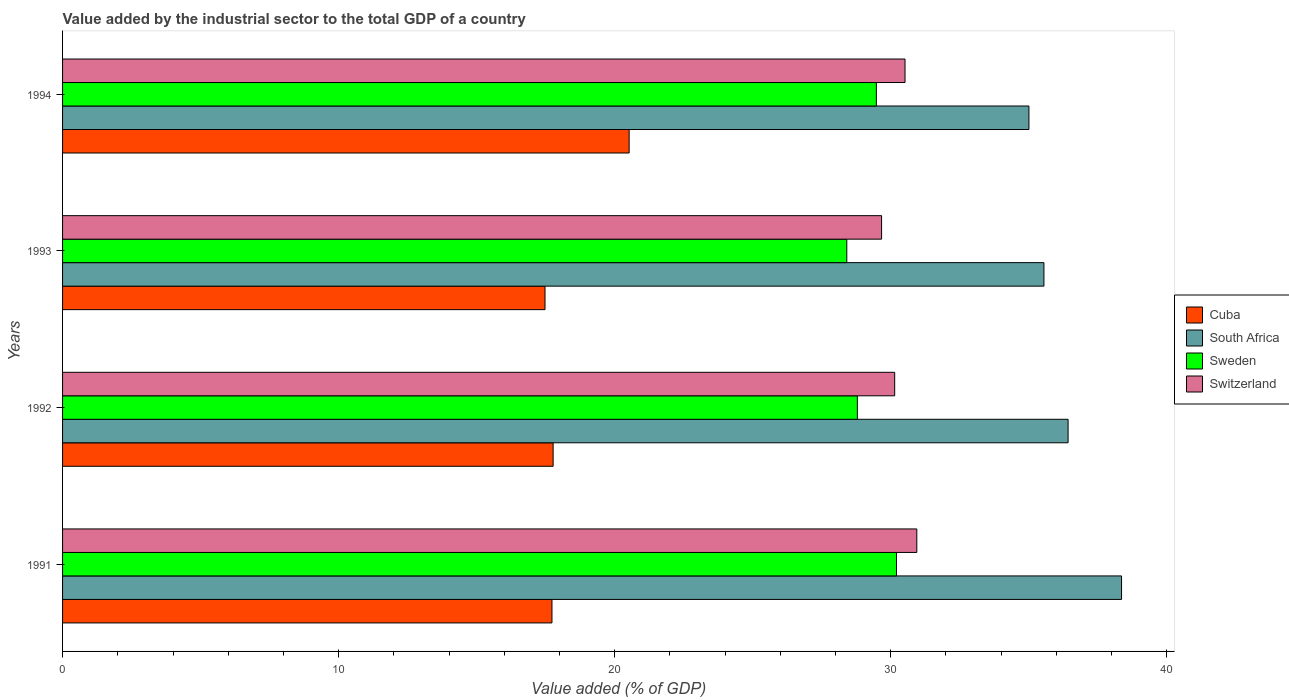How many different coloured bars are there?
Provide a short and direct response. 4. How many bars are there on the 3rd tick from the bottom?
Your answer should be very brief. 4. What is the label of the 1st group of bars from the top?
Your answer should be very brief. 1994. What is the value added by the industrial sector to the total GDP in South Africa in 1994?
Ensure brevity in your answer.  35. Across all years, what is the maximum value added by the industrial sector to the total GDP in Sweden?
Offer a terse response. 30.21. Across all years, what is the minimum value added by the industrial sector to the total GDP in Sweden?
Provide a succinct answer. 28.41. In which year was the value added by the industrial sector to the total GDP in Switzerland minimum?
Provide a short and direct response. 1993. What is the total value added by the industrial sector to the total GDP in Sweden in the graph?
Your answer should be compact. 116.88. What is the difference between the value added by the industrial sector to the total GDP in Cuba in 1991 and that in 1994?
Your response must be concise. -2.8. What is the difference between the value added by the industrial sector to the total GDP in Cuba in 1994 and the value added by the industrial sector to the total GDP in South Africa in 1991?
Provide a succinct answer. -17.84. What is the average value added by the industrial sector to the total GDP in Cuba per year?
Keep it short and to the point. 18.37. In the year 1994, what is the difference between the value added by the industrial sector to the total GDP in South Africa and value added by the industrial sector to the total GDP in Switzerland?
Your answer should be compact. 4.49. What is the ratio of the value added by the industrial sector to the total GDP in Cuba in 1991 to that in 1993?
Ensure brevity in your answer.  1.01. Is the value added by the industrial sector to the total GDP in Switzerland in 1993 less than that in 1994?
Your response must be concise. Yes. What is the difference between the highest and the second highest value added by the industrial sector to the total GDP in South Africa?
Offer a terse response. 1.94. What is the difference between the highest and the lowest value added by the industrial sector to the total GDP in Cuba?
Offer a terse response. 3.05. In how many years, is the value added by the industrial sector to the total GDP in Cuba greater than the average value added by the industrial sector to the total GDP in Cuba taken over all years?
Provide a succinct answer. 1. Is it the case that in every year, the sum of the value added by the industrial sector to the total GDP in Cuba and value added by the industrial sector to the total GDP in Sweden is greater than the sum of value added by the industrial sector to the total GDP in South Africa and value added by the industrial sector to the total GDP in Switzerland?
Provide a short and direct response. No. What does the 3rd bar from the top in 1994 represents?
Ensure brevity in your answer.  South Africa. What does the 4th bar from the bottom in 1993 represents?
Your answer should be compact. Switzerland. Is it the case that in every year, the sum of the value added by the industrial sector to the total GDP in Switzerland and value added by the industrial sector to the total GDP in South Africa is greater than the value added by the industrial sector to the total GDP in Sweden?
Provide a short and direct response. Yes. How many bars are there?
Make the answer very short. 16. Are all the bars in the graph horizontal?
Your answer should be very brief. Yes. How many years are there in the graph?
Your answer should be compact. 4. What is the difference between two consecutive major ticks on the X-axis?
Provide a succinct answer. 10. Does the graph contain any zero values?
Make the answer very short. No. Where does the legend appear in the graph?
Ensure brevity in your answer.  Center right. How many legend labels are there?
Give a very brief answer. 4. What is the title of the graph?
Keep it short and to the point. Value added by the industrial sector to the total GDP of a country. Does "Trinidad and Tobago" appear as one of the legend labels in the graph?
Make the answer very short. No. What is the label or title of the X-axis?
Your response must be concise. Value added (% of GDP). What is the Value added (% of GDP) in Cuba in 1991?
Give a very brief answer. 17.73. What is the Value added (% of GDP) of South Africa in 1991?
Make the answer very short. 38.36. What is the Value added (% of GDP) in Sweden in 1991?
Give a very brief answer. 30.21. What is the Value added (% of GDP) of Switzerland in 1991?
Ensure brevity in your answer.  30.94. What is the Value added (% of GDP) of Cuba in 1992?
Offer a terse response. 17.77. What is the Value added (% of GDP) in South Africa in 1992?
Offer a very short reply. 36.42. What is the Value added (% of GDP) of Sweden in 1992?
Your answer should be very brief. 28.79. What is the Value added (% of GDP) in Switzerland in 1992?
Your answer should be very brief. 30.14. What is the Value added (% of GDP) of Cuba in 1993?
Provide a succinct answer. 17.48. What is the Value added (% of GDP) of South Africa in 1993?
Ensure brevity in your answer.  35.55. What is the Value added (% of GDP) in Sweden in 1993?
Provide a short and direct response. 28.41. What is the Value added (% of GDP) of Switzerland in 1993?
Your response must be concise. 29.67. What is the Value added (% of GDP) of Cuba in 1994?
Make the answer very short. 20.52. What is the Value added (% of GDP) of South Africa in 1994?
Give a very brief answer. 35. What is the Value added (% of GDP) in Sweden in 1994?
Your answer should be compact. 29.48. What is the Value added (% of GDP) of Switzerland in 1994?
Give a very brief answer. 30.52. Across all years, what is the maximum Value added (% of GDP) in Cuba?
Provide a short and direct response. 20.52. Across all years, what is the maximum Value added (% of GDP) of South Africa?
Provide a short and direct response. 38.36. Across all years, what is the maximum Value added (% of GDP) in Sweden?
Offer a terse response. 30.21. Across all years, what is the maximum Value added (% of GDP) of Switzerland?
Keep it short and to the point. 30.94. Across all years, what is the minimum Value added (% of GDP) of Cuba?
Ensure brevity in your answer.  17.48. Across all years, what is the minimum Value added (% of GDP) of South Africa?
Make the answer very short. 35. Across all years, what is the minimum Value added (% of GDP) of Sweden?
Provide a short and direct response. 28.41. Across all years, what is the minimum Value added (% of GDP) in Switzerland?
Your answer should be very brief. 29.67. What is the total Value added (% of GDP) of Cuba in the graph?
Provide a short and direct response. 73.5. What is the total Value added (% of GDP) in South Africa in the graph?
Your response must be concise. 145.34. What is the total Value added (% of GDP) in Sweden in the graph?
Make the answer very short. 116.88. What is the total Value added (% of GDP) in Switzerland in the graph?
Ensure brevity in your answer.  121.27. What is the difference between the Value added (% of GDP) in Cuba in 1991 and that in 1992?
Your answer should be compact. -0.04. What is the difference between the Value added (% of GDP) of South Africa in 1991 and that in 1992?
Your answer should be very brief. 1.94. What is the difference between the Value added (% of GDP) of Sweden in 1991 and that in 1992?
Your response must be concise. 1.42. What is the difference between the Value added (% of GDP) of Switzerland in 1991 and that in 1992?
Your answer should be very brief. 0.8. What is the difference between the Value added (% of GDP) of Cuba in 1991 and that in 1993?
Keep it short and to the point. 0.25. What is the difference between the Value added (% of GDP) of South Africa in 1991 and that in 1993?
Provide a succinct answer. 2.81. What is the difference between the Value added (% of GDP) in Sweden in 1991 and that in 1993?
Give a very brief answer. 1.8. What is the difference between the Value added (% of GDP) in Switzerland in 1991 and that in 1993?
Make the answer very short. 1.28. What is the difference between the Value added (% of GDP) in Cuba in 1991 and that in 1994?
Make the answer very short. -2.8. What is the difference between the Value added (% of GDP) of South Africa in 1991 and that in 1994?
Make the answer very short. 3.35. What is the difference between the Value added (% of GDP) of Sweden in 1991 and that in 1994?
Your answer should be very brief. 0.73. What is the difference between the Value added (% of GDP) in Switzerland in 1991 and that in 1994?
Make the answer very short. 0.43. What is the difference between the Value added (% of GDP) in Cuba in 1992 and that in 1993?
Make the answer very short. 0.29. What is the difference between the Value added (% of GDP) in South Africa in 1992 and that in 1993?
Provide a short and direct response. 0.88. What is the difference between the Value added (% of GDP) of Sweden in 1992 and that in 1993?
Your response must be concise. 0.38. What is the difference between the Value added (% of GDP) of Switzerland in 1992 and that in 1993?
Your answer should be compact. 0.47. What is the difference between the Value added (% of GDP) of Cuba in 1992 and that in 1994?
Your response must be concise. -2.75. What is the difference between the Value added (% of GDP) in South Africa in 1992 and that in 1994?
Keep it short and to the point. 1.42. What is the difference between the Value added (% of GDP) in Sweden in 1992 and that in 1994?
Your answer should be very brief. -0.69. What is the difference between the Value added (% of GDP) in Switzerland in 1992 and that in 1994?
Provide a short and direct response. -0.37. What is the difference between the Value added (% of GDP) of Cuba in 1993 and that in 1994?
Provide a succinct answer. -3.05. What is the difference between the Value added (% of GDP) of South Africa in 1993 and that in 1994?
Provide a short and direct response. 0.54. What is the difference between the Value added (% of GDP) in Sweden in 1993 and that in 1994?
Ensure brevity in your answer.  -1.07. What is the difference between the Value added (% of GDP) of Switzerland in 1993 and that in 1994?
Provide a short and direct response. -0.85. What is the difference between the Value added (% of GDP) in Cuba in 1991 and the Value added (% of GDP) in South Africa in 1992?
Give a very brief answer. -18.7. What is the difference between the Value added (% of GDP) of Cuba in 1991 and the Value added (% of GDP) of Sweden in 1992?
Provide a succinct answer. -11.06. What is the difference between the Value added (% of GDP) in Cuba in 1991 and the Value added (% of GDP) in Switzerland in 1992?
Your answer should be compact. -12.41. What is the difference between the Value added (% of GDP) of South Africa in 1991 and the Value added (% of GDP) of Sweden in 1992?
Give a very brief answer. 9.57. What is the difference between the Value added (% of GDP) in South Africa in 1991 and the Value added (% of GDP) in Switzerland in 1992?
Keep it short and to the point. 8.22. What is the difference between the Value added (% of GDP) of Sweden in 1991 and the Value added (% of GDP) of Switzerland in 1992?
Ensure brevity in your answer.  0.07. What is the difference between the Value added (% of GDP) of Cuba in 1991 and the Value added (% of GDP) of South Africa in 1993?
Your response must be concise. -17.82. What is the difference between the Value added (% of GDP) in Cuba in 1991 and the Value added (% of GDP) in Sweden in 1993?
Provide a succinct answer. -10.68. What is the difference between the Value added (% of GDP) in Cuba in 1991 and the Value added (% of GDP) in Switzerland in 1993?
Your answer should be very brief. -11.94. What is the difference between the Value added (% of GDP) of South Africa in 1991 and the Value added (% of GDP) of Sweden in 1993?
Your answer should be compact. 9.95. What is the difference between the Value added (% of GDP) of South Africa in 1991 and the Value added (% of GDP) of Switzerland in 1993?
Your answer should be very brief. 8.69. What is the difference between the Value added (% of GDP) in Sweden in 1991 and the Value added (% of GDP) in Switzerland in 1993?
Provide a succinct answer. 0.54. What is the difference between the Value added (% of GDP) in Cuba in 1991 and the Value added (% of GDP) in South Africa in 1994?
Offer a terse response. -17.28. What is the difference between the Value added (% of GDP) in Cuba in 1991 and the Value added (% of GDP) in Sweden in 1994?
Your answer should be compact. -11.75. What is the difference between the Value added (% of GDP) of Cuba in 1991 and the Value added (% of GDP) of Switzerland in 1994?
Give a very brief answer. -12.79. What is the difference between the Value added (% of GDP) of South Africa in 1991 and the Value added (% of GDP) of Sweden in 1994?
Offer a terse response. 8.88. What is the difference between the Value added (% of GDP) in South Africa in 1991 and the Value added (% of GDP) in Switzerland in 1994?
Your response must be concise. 7.84. What is the difference between the Value added (% of GDP) in Sweden in 1991 and the Value added (% of GDP) in Switzerland in 1994?
Ensure brevity in your answer.  -0.31. What is the difference between the Value added (% of GDP) in Cuba in 1992 and the Value added (% of GDP) in South Africa in 1993?
Provide a succinct answer. -17.78. What is the difference between the Value added (% of GDP) in Cuba in 1992 and the Value added (% of GDP) in Sweden in 1993?
Your answer should be very brief. -10.64. What is the difference between the Value added (% of GDP) of Cuba in 1992 and the Value added (% of GDP) of Switzerland in 1993?
Provide a short and direct response. -11.9. What is the difference between the Value added (% of GDP) of South Africa in 1992 and the Value added (% of GDP) of Sweden in 1993?
Keep it short and to the point. 8.02. What is the difference between the Value added (% of GDP) in South Africa in 1992 and the Value added (% of GDP) in Switzerland in 1993?
Provide a short and direct response. 6.76. What is the difference between the Value added (% of GDP) in Sweden in 1992 and the Value added (% of GDP) in Switzerland in 1993?
Provide a short and direct response. -0.88. What is the difference between the Value added (% of GDP) of Cuba in 1992 and the Value added (% of GDP) of South Africa in 1994?
Make the answer very short. -17.24. What is the difference between the Value added (% of GDP) of Cuba in 1992 and the Value added (% of GDP) of Sweden in 1994?
Make the answer very short. -11.71. What is the difference between the Value added (% of GDP) in Cuba in 1992 and the Value added (% of GDP) in Switzerland in 1994?
Provide a short and direct response. -12.75. What is the difference between the Value added (% of GDP) of South Africa in 1992 and the Value added (% of GDP) of Sweden in 1994?
Your answer should be compact. 6.95. What is the difference between the Value added (% of GDP) of South Africa in 1992 and the Value added (% of GDP) of Switzerland in 1994?
Keep it short and to the point. 5.91. What is the difference between the Value added (% of GDP) in Sweden in 1992 and the Value added (% of GDP) in Switzerland in 1994?
Make the answer very short. -1.73. What is the difference between the Value added (% of GDP) in Cuba in 1993 and the Value added (% of GDP) in South Africa in 1994?
Give a very brief answer. -17.53. What is the difference between the Value added (% of GDP) of Cuba in 1993 and the Value added (% of GDP) of Sweden in 1994?
Your answer should be compact. -12. What is the difference between the Value added (% of GDP) in Cuba in 1993 and the Value added (% of GDP) in Switzerland in 1994?
Your answer should be compact. -13.04. What is the difference between the Value added (% of GDP) of South Africa in 1993 and the Value added (% of GDP) of Sweden in 1994?
Keep it short and to the point. 6.07. What is the difference between the Value added (% of GDP) of South Africa in 1993 and the Value added (% of GDP) of Switzerland in 1994?
Your answer should be compact. 5.03. What is the difference between the Value added (% of GDP) in Sweden in 1993 and the Value added (% of GDP) in Switzerland in 1994?
Offer a very short reply. -2.11. What is the average Value added (% of GDP) in Cuba per year?
Provide a short and direct response. 18.37. What is the average Value added (% of GDP) in South Africa per year?
Keep it short and to the point. 36.33. What is the average Value added (% of GDP) of Sweden per year?
Offer a very short reply. 29.22. What is the average Value added (% of GDP) in Switzerland per year?
Provide a short and direct response. 30.32. In the year 1991, what is the difference between the Value added (% of GDP) in Cuba and Value added (% of GDP) in South Africa?
Provide a short and direct response. -20.63. In the year 1991, what is the difference between the Value added (% of GDP) in Cuba and Value added (% of GDP) in Sweden?
Your answer should be compact. -12.48. In the year 1991, what is the difference between the Value added (% of GDP) of Cuba and Value added (% of GDP) of Switzerland?
Your answer should be very brief. -13.22. In the year 1991, what is the difference between the Value added (% of GDP) in South Africa and Value added (% of GDP) in Sweden?
Keep it short and to the point. 8.15. In the year 1991, what is the difference between the Value added (% of GDP) of South Africa and Value added (% of GDP) of Switzerland?
Offer a very short reply. 7.42. In the year 1991, what is the difference between the Value added (% of GDP) in Sweden and Value added (% of GDP) in Switzerland?
Give a very brief answer. -0.74. In the year 1992, what is the difference between the Value added (% of GDP) in Cuba and Value added (% of GDP) in South Africa?
Offer a very short reply. -18.65. In the year 1992, what is the difference between the Value added (% of GDP) in Cuba and Value added (% of GDP) in Sweden?
Offer a terse response. -11.02. In the year 1992, what is the difference between the Value added (% of GDP) of Cuba and Value added (% of GDP) of Switzerland?
Give a very brief answer. -12.37. In the year 1992, what is the difference between the Value added (% of GDP) of South Africa and Value added (% of GDP) of Sweden?
Your answer should be compact. 7.63. In the year 1992, what is the difference between the Value added (% of GDP) of South Africa and Value added (% of GDP) of Switzerland?
Give a very brief answer. 6.28. In the year 1992, what is the difference between the Value added (% of GDP) in Sweden and Value added (% of GDP) in Switzerland?
Your answer should be very brief. -1.35. In the year 1993, what is the difference between the Value added (% of GDP) in Cuba and Value added (% of GDP) in South Africa?
Offer a terse response. -18.07. In the year 1993, what is the difference between the Value added (% of GDP) of Cuba and Value added (% of GDP) of Sweden?
Your answer should be very brief. -10.93. In the year 1993, what is the difference between the Value added (% of GDP) in Cuba and Value added (% of GDP) in Switzerland?
Make the answer very short. -12.19. In the year 1993, what is the difference between the Value added (% of GDP) in South Africa and Value added (% of GDP) in Sweden?
Offer a very short reply. 7.14. In the year 1993, what is the difference between the Value added (% of GDP) in South Africa and Value added (% of GDP) in Switzerland?
Your answer should be very brief. 5.88. In the year 1993, what is the difference between the Value added (% of GDP) of Sweden and Value added (% of GDP) of Switzerland?
Your response must be concise. -1.26. In the year 1994, what is the difference between the Value added (% of GDP) of Cuba and Value added (% of GDP) of South Africa?
Provide a succinct answer. -14.48. In the year 1994, what is the difference between the Value added (% of GDP) in Cuba and Value added (% of GDP) in Sweden?
Offer a terse response. -8.96. In the year 1994, what is the difference between the Value added (% of GDP) in Cuba and Value added (% of GDP) in Switzerland?
Your response must be concise. -9.99. In the year 1994, what is the difference between the Value added (% of GDP) in South Africa and Value added (% of GDP) in Sweden?
Your answer should be very brief. 5.53. In the year 1994, what is the difference between the Value added (% of GDP) of South Africa and Value added (% of GDP) of Switzerland?
Provide a short and direct response. 4.49. In the year 1994, what is the difference between the Value added (% of GDP) in Sweden and Value added (% of GDP) in Switzerland?
Your response must be concise. -1.04. What is the ratio of the Value added (% of GDP) in Cuba in 1991 to that in 1992?
Offer a very short reply. 1. What is the ratio of the Value added (% of GDP) of South Africa in 1991 to that in 1992?
Your answer should be very brief. 1.05. What is the ratio of the Value added (% of GDP) in Sweden in 1991 to that in 1992?
Provide a succinct answer. 1.05. What is the ratio of the Value added (% of GDP) of Switzerland in 1991 to that in 1992?
Provide a succinct answer. 1.03. What is the ratio of the Value added (% of GDP) of Cuba in 1991 to that in 1993?
Your answer should be compact. 1.01. What is the ratio of the Value added (% of GDP) of South Africa in 1991 to that in 1993?
Give a very brief answer. 1.08. What is the ratio of the Value added (% of GDP) of Sweden in 1991 to that in 1993?
Offer a terse response. 1.06. What is the ratio of the Value added (% of GDP) in Switzerland in 1991 to that in 1993?
Ensure brevity in your answer.  1.04. What is the ratio of the Value added (% of GDP) in Cuba in 1991 to that in 1994?
Your answer should be very brief. 0.86. What is the ratio of the Value added (% of GDP) in South Africa in 1991 to that in 1994?
Keep it short and to the point. 1.1. What is the ratio of the Value added (% of GDP) in Sweden in 1991 to that in 1994?
Provide a succinct answer. 1.02. What is the ratio of the Value added (% of GDP) in Cuba in 1992 to that in 1993?
Keep it short and to the point. 1.02. What is the ratio of the Value added (% of GDP) in South Africa in 1992 to that in 1993?
Offer a very short reply. 1.02. What is the ratio of the Value added (% of GDP) in Sweden in 1992 to that in 1993?
Your answer should be very brief. 1.01. What is the ratio of the Value added (% of GDP) in Switzerland in 1992 to that in 1993?
Your answer should be compact. 1.02. What is the ratio of the Value added (% of GDP) in Cuba in 1992 to that in 1994?
Your response must be concise. 0.87. What is the ratio of the Value added (% of GDP) of South Africa in 1992 to that in 1994?
Your response must be concise. 1.04. What is the ratio of the Value added (% of GDP) of Sweden in 1992 to that in 1994?
Your answer should be compact. 0.98. What is the ratio of the Value added (% of GDP) in Cuba in 1993 to that in 1994?
Provide a succinct answer. 0.85. What is the ratio of the Value added (% of GDP) in South Africa in 1993 to that in 1994?
Your answer should be compact. 1.02. What is the ratio of the Value added (% of GDP) of Sweden in 1993 to that in 1994?
Your response must be concise. 0.96. What is the ratio of the Value added (% of GDP) in Switzerland in 1993 to that in 1994?
Offer a terse response. 0.97. What is the difference between the highest and the second highest Value added (% of GDP) of Cuba?
Give a very brief answer. 2.75. What is the difference between the highest and the second highest Value added (% of GDP) of South Africa?
Ensure brevity in your answer.  1.94. What is the difference between the highest and the second highest Value added (% of GDP) of Sweden?
Your answer should be very brief. 0.73. What is the difference between the highest and the second highest Value added (% of GDP) in Switzerland?
Your response must be concise. 0.43. What is the difference between the highest and the lowest Value added (% of GDP) of Cuba?
Ensure brevity in your answer.  3.05. What is the difference between the highest and the lowest Value added (% of GDP) of South Africa?
Your answer should be very brief. 3.35. What is the difference between the highest and the lowest Value added (% of GDP) of Sweden?
Your answer should be compact. 1.8. What is the difference between the highest and the lowest Value added (% of GDP) in Switzerland?
Your answer should be compact. 1.28. 